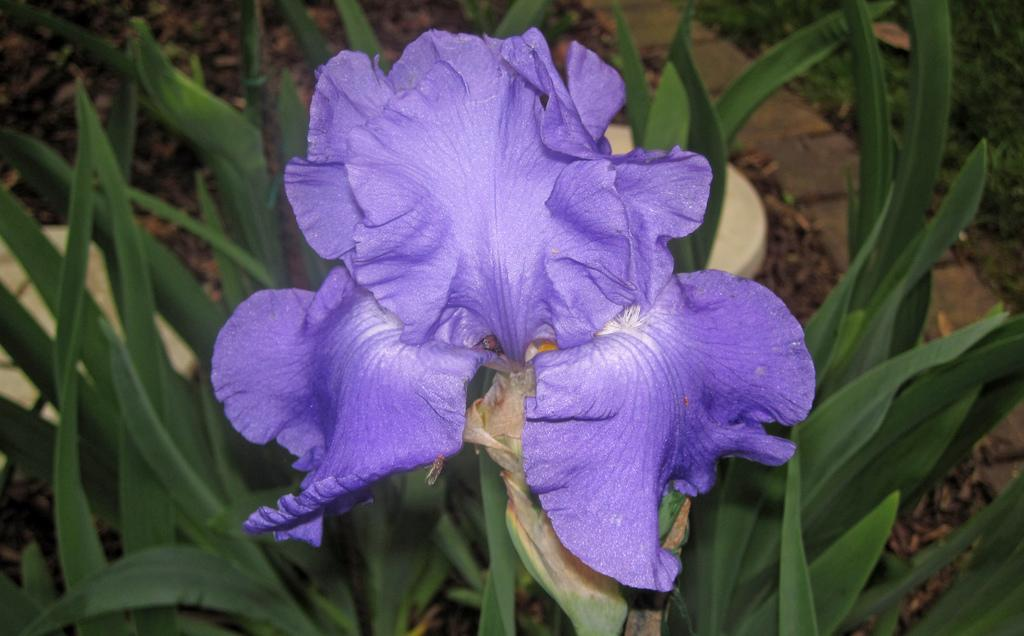What type of image is shown? The image is a zoomed-in picture. What can be seen in the zoomed-in image? There is a violet-colored flower in the image. Is the flower part of a larger object or plant? Yes, the flower is part of a plant. What type of drum is being played by the daughter in the image? There is no daughter or drum present in the image; it features a zoomed-in picture of a violet-colored flower that is part of a plant. Is the corn growing near the flower in the image? There is no corn present in the image; it only features a violet-colored flower that is part of a plant. 